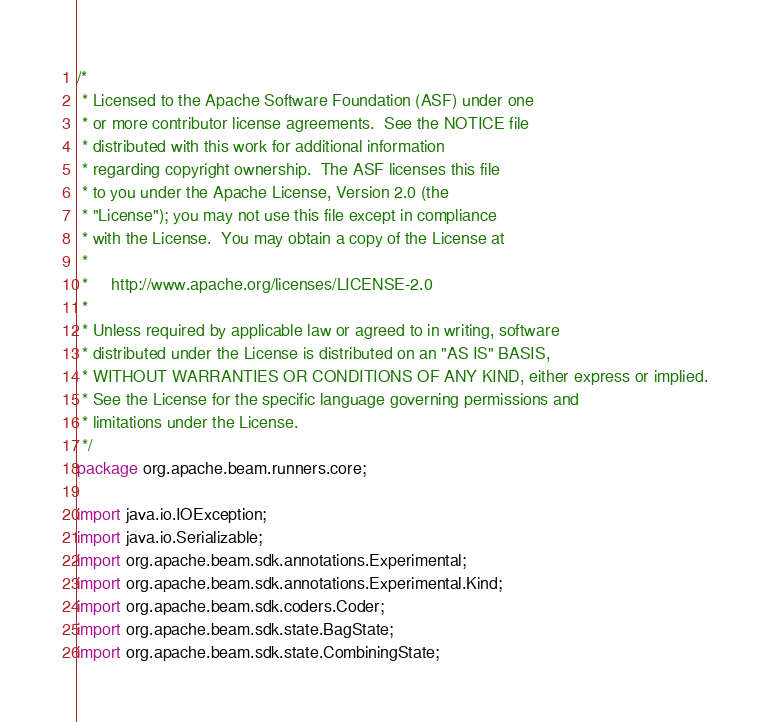<code> <loc_0><loc_0><loc_500><loc_500><_Java_>/*
 * Licensed to the Apache Software Foundation (ASF) under one
 * or more contributor license agreements.  See the NOTICE file
 * distributed with this work for additional information
 * regarding copyright ownership.  The ASF licenses this file
 * to you under the Apache License, Version 2.0 (the
 * "License"); you may not use this file except in compliance
 * with the License.  You may obtain a copy of the License at
 *
 *     http://www.apache.org/licenses/LICENSE-2.0
 *
 * Unless required by applicable law or agreed to in writing, software
 * distributed under the License is distributed on an "AS IS" BASIS,
 * WITHOUT WARRANTIES OR CONDITIONS OF ANY KIND, either express or implied.
 * See the License for the specific language governing permissions and
 * limitations under the License.
 */
package org.apache.beam.runners.core;

import java.io.IOException;
import java.io.Serializable;
import org.apache.beam.sdk.annotations.Experimental;
import org.apache.beam.sdk.annotations.Experimental.Kind;
import org.apache.beam.sdk.coders.Coder;
import org.apache.beam.sdk.state.BagState;
import org.apache.beam.sdk.state.CombiningState;</code> 